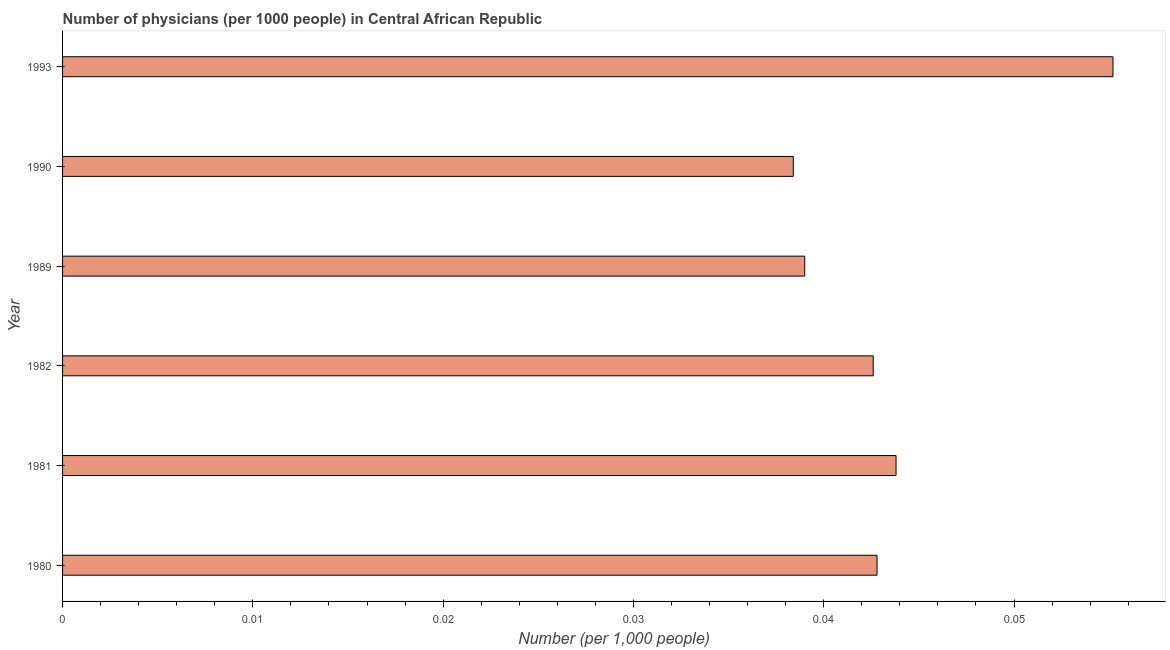Does the graph contain any zero values?
Keep it short and to the point. No. Does the graph contain grids?
Offer a very short reply. No. What is the title of the graph?
Provide a succinct answer. Number of physicians (per 1000 people) in Central African Republic. What is the label or title of the X-axis?
Your answer should be compact. Number (per 1,0 people). What is the number of physicians in 1990?
Ensure brevity in your answer.  0.04. Across all years, what is the maximum number of physicians?
Make the answer very short. 0.06. Across all years, what is the minimum number of physicians?
Give a very brief answer. 0.04. In which year was the number of physicians maximum?
Make the answer very short. 1993. What is the sum of the number of physicians?
Provide a short and direct response. 0.26. What is the difference between the number of physicians in 1980 and 1981?
Provide a succinct answer. -0. What is the average number of physicians per year?
Give a very brief answer. 0.04. What is the median number of physicians?
Ensure brevity in your answer.  0.04. In how many years, is the number of physicians greater than 0.03 ?
Ensure brevity in your answer.  6. Is the number of physicians in 1980 less than that in 1990?
Your response must be concise. No. What is the difference between the highest and the second highest number of physicians?
Keep it short and to the point. 0.01. What is the difference between the highest and the lowest number of physicians?
Make the answer very short. 0.02. In how many years, is the number of physicians greater than the average number of physicians taken over all years?
Provide a short and direct response. 2. Are all the bars in the graph horizontal?
Offer a very short reply. Yes. What is the difference between two consecutive major ticks on the X-axis?
Give a very brief answer. 0.01. Are the values on the major ticks of X-axis written in scientific E-notation?
Offer a terse response. No. What is the Number (per 1,000 people) in 1980?
Your answer should be very brief. 0.04. What is the Number (per 1,000 people) of 1981?
Offer a very short reply. 0.04. What is the Number (per 1,000 people) of 1982?
Offer a terse response. 0.04. What is the Number (per 1,000 people) of 1989?
Give a very brief answer. 0.04. What is the Number (per 1,000 people) of 1990?
Ensure brevity in your answer.  0.04. What is the Number (per 1,000 people) of 1993?
Keep it short and to the point. 0.06. What is the difference between the Number (per 1,000 people) in 1980 and 1981?
Keep it short and to the point. -0. What is the difference between the Number (per 1,000 people) in 1980 and 1982?
Your answer should be compact. 0. What is the difference between the Number (per 1,000 people) in 1980 and 1989?
Provide a succinct answer. 0. What is the difference between the Number (per 1,000 people) in 1980 and 1990?
Make the answer very short. 0. What is the difference between the Number (per 1,000 people) in 1980 and 1993?
Ensure brevity in your answer.  -0.01. What is the difference between the Number (per 1,000 people) in 1981 and 1982?
Your response must be concise. 0. What is the difference between the Number (per 1,000 people) in 1981 and 1989?
Your answer should be compact. 0. What is the difference between the Number (per 1,000 people) in 1981 and 1990?
Your answer should be compact. 0.01. What is the difference between the Number (per 1,000 people) in 1981 and 1993?
Offer a very short reply. -0.01. What is the difference between the Number (per 1,000 people) in 1982 and 1989?
Offer a very short reply. 0. What is the difference between the Number (per 1,000 people) in 1982 and 1990?
Provide a succinct answer. 0. What is the difference between the Number (per 1,000 people) in 1982 and 1993?
Offer a terse response. -0.01. What is the difference between the Number (per 1,000 people) in 1989 and 1990?
Offer a terse response. 0. What is the difference between the Number (per 1,000 people) in 1989 and 1993?
Ensure brevity in your answer.  -0.02. What is the difference between the Number (per 1,000 people) in 1990 and 1993?
Offer a terse response. -0.02. What is the ratio of the Number (per 1,000 people) in 1980 to that in 1981?
Keep it short and to the point. 0.98. What is the ratio of the Number (per 1,000 people) in 1980 to that in 1989?
Give a very brief answer. 1.1. What is the ratio of the Number (per 1,000 people) in 1980 to that in 1990?
Provide a succinct answer. 1.11. What is the ratio of the Number (per 1,000 people) in 1980 to that in 1993?
Offer a very short reply. 0.78. What is the ratio of the Number (per 1,000 people) in 1981 to that in 1982?
Your response must be concise. 1.03. What is the ratio of the Number (per 1,000 people) in 1981 to that in 1989?
Give a very brief answer. 1.12. What is the ratio of the Number (per 1,000 people) in 1981 to that in 1990?
Keep it short and to the point. 1.14. What is the ratio of the Number (per 1,000 people) in 1981 to that in 1993?
Ensure brevity in your answer.  0.79. What is the ratio of the Number (per 1,000 people) in 1982 to that in 1989?
Offer a terse response. 1.09. What is the ratio of the Number (per 1,000 people) in 1982 to that in 1990?
Ensure brevity in your answer.  1.11. What is the ratio of the Number (per 1,000 people) in 1982 to that in 1993?
Your answer should be compact. 0.77. What is the ratio of the Number (per 1,000 people) in 1989 to that in 1993?
Your response must be concise. 0.71. What is the ratio of the Number (per 1,000 people) in 1990 to that in 1993?
Offer a terse response. 0.7. 